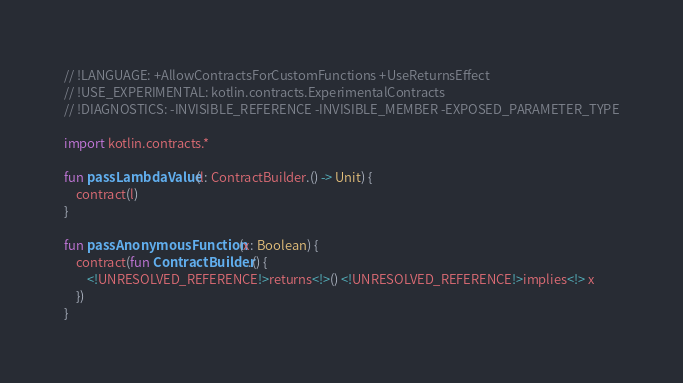<code> <loc_0><loc_0><loc_500><loc_500><_Kotlin_>// !LANGUAGE: +AllowContractsForCustomFunctions +UseReturnsEffect
// !USE_EXPERIMENTAL: kotlin.contracts.ExperimentalContracts
// !DIAGNOSTICS: -INVISIBLE_REFERENCE -INVISIBLE_MEMBER -EXPOSED_PARAMETER_TYPE

import kotlin.contracts.*

fun passLambdaValue(l: ContractBuilder.() -> Unit) {
    contract(l)
}

fun passAnonymousFunction(x: Boolean) {
    contract(fun ContractBuilder.() {
        <!UNRESOLVED_REFERENCE!>returns<!>() <!UNRESOLVED_REFERENCE!>implies<!> x
    })
}</code> 